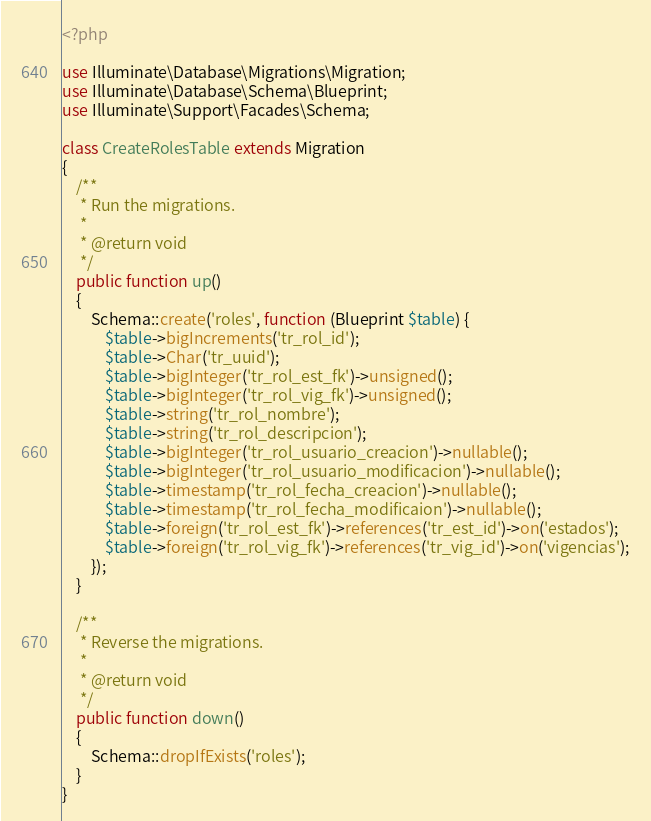Convert code to text. <code><loc_0><loc_0><loc_500><loc_500><_PHP_><?php

use Illuminate\Database\Migrations\Migration;
use Illuminate\Database\Schema\Blueprint;
use Illuminate\Support\Facades\Schema;

class CreateRolesTable extends Migration
{
    /**
     * Run the migrations.
     *
     * @return void
     */
    public function up()
    {
        Schema::create('roles', function (Blueprint $table) {
            $table->bigIncrements('tr_rol_id');
            $table->Char('tr_uuid');
            $table->bigInteger('tr_rol_est_fk')->unsigned();
            $table->bigInteger('tr_rol_vig_fk')->unsigned();
            $table->string('tr_rol_nombre');
            $table->string('tr_rol_descripcion');
            $table->bigInteger('tr_rol_usuario_creacion')->nullable();
            $table->bigInteger('tr_rol_usuario_modificacion')->nullable();
            $table->timestamp('tr_rol_fecha_creacion')->nullable();
            $table->timestamp('tr_rol_fecha_modificaion')->nullable();
            $table->foreign('tr_rol_est_fk')->references('tr_est_id')->on('estados');
            $table->foreign('tr_rol_vig_fk')->references('tr_vig_id')->on('vigencias');
        });
    }

    /**
     * Reverse the migrations.
     *
     * @return void
     */
    public function down()
    {
        Schema::dropIfExists('roles');
    }
}
</code> 